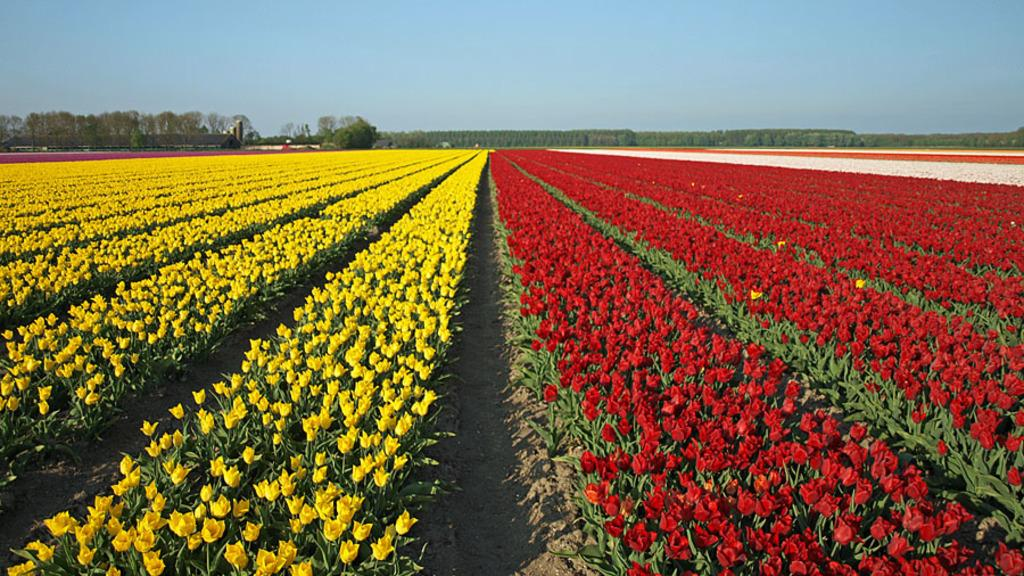What type of natural landscape is depicted in the image? There are flower fields in the image. What other natural elements can be seen in the image? There are trees in the image. What is visible in the sky in the image? There are clouds visible in the sky in the image. Where is the office located in the image? There is no office present in the image; it features a natural landscape with flower fields and trees. How many trucks can be seen driving through the flower fields in the image? There are no trucks visible in the image. 